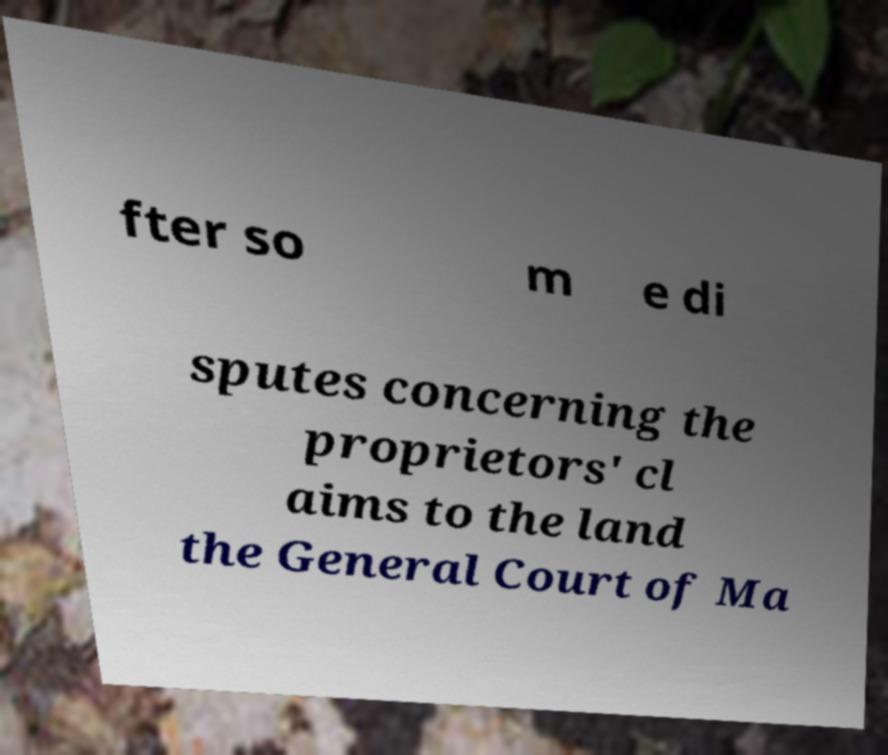There's text embedded in this image that I need extracted. Can you transcribe it verbatim? fter so m e di sputes concerning the proprietors' cl aims to the land the General Court of Ma 